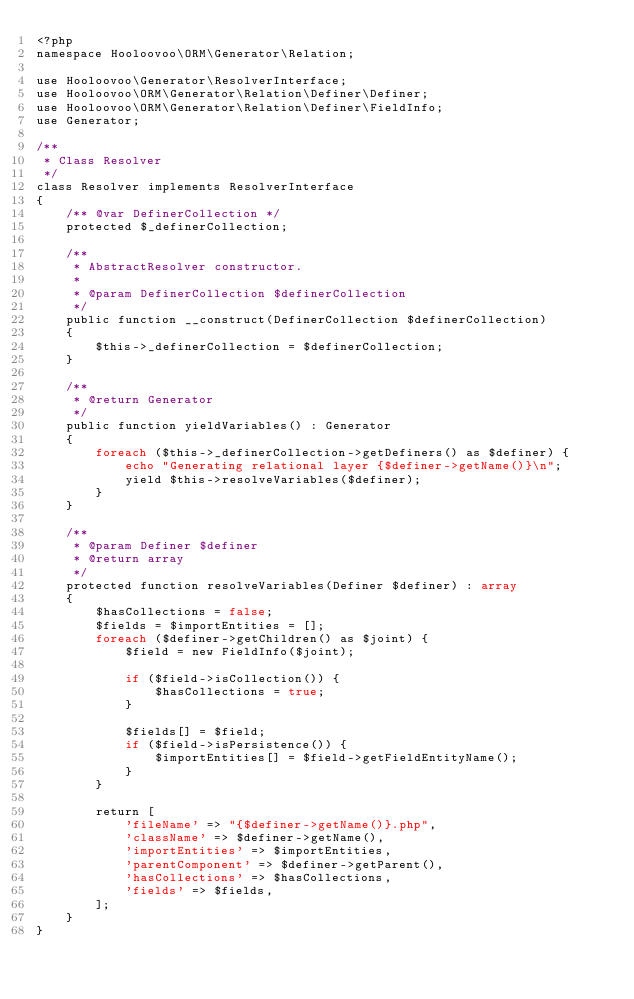<code> <loc_0><loc_0><loc_500><loc_500><_PHP_><?php
namespace Hooloovoo\ORM\Generator\Relation;

use Hooloovoo\Generator\ResolverInterface;
use Hooloovoo\ORM\Generator\Relation\Definer\Definer;
use Hooloovoo\ORM\Generator\Relation\Definer\FieldInfo;
use Generator;

/**
 * Class Resolver
 */
class Resolver implements ResolverInterface
{
    /** @var DefinerCollection */
    protected $_definerCollection;

    /**
     * AbstractResolver constructor.
     *
     * @param DefinerCollection $definerCollection
     */
    public function __construct(DefinerCollection $definerCollection)
    {
        $this->_definerCollection = $definerCollection;
    }

    /**
     * @return Generator
     */
    public function yieldVariables() : Generator
    {
        foreach ($this->_definerCollection->getDefiners() as $definer) {
            echo "Generating relational layer {$definer->getName()}\n";
            yield $this->resolveVariables($definer);
        }
    }

    /**
     * @param Definer $definer
     * @return array
     */
    protected function resolveVariables(Definer $definer) : array
    {
        $hasCollections = false;
        $fields = $importEntities = [];
        foreach ($definer->getChildren() as $joint) {
            $field = new FieldInfo($joint);

            if ($field->isCollection()) {
                $hasCollections = true;
            }

            $fields[] = $field;
            if ($field->isPersistence()) {
                $importEntities[] = $field->getFieldEntityName();
            }
        }

        return [
            'fileName' => "{$definer->getName()}.php",
            'className' => $definer->getName(),
            'importEntities' => $importEntities,
            'parentComponent' => $definer->getParent(),
            'hasCollections' => $hasCollections,
            'fields' => $fields,
        ];
    }
}</code> 